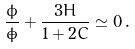<formula> <loc_0><loc_0><loc_500><loc_500>\frac { \ddot { \phi } } { \dot { \phi } } + \frac { 3 H } { 1 + 2 C } \simeq 0 \, .</formula> 